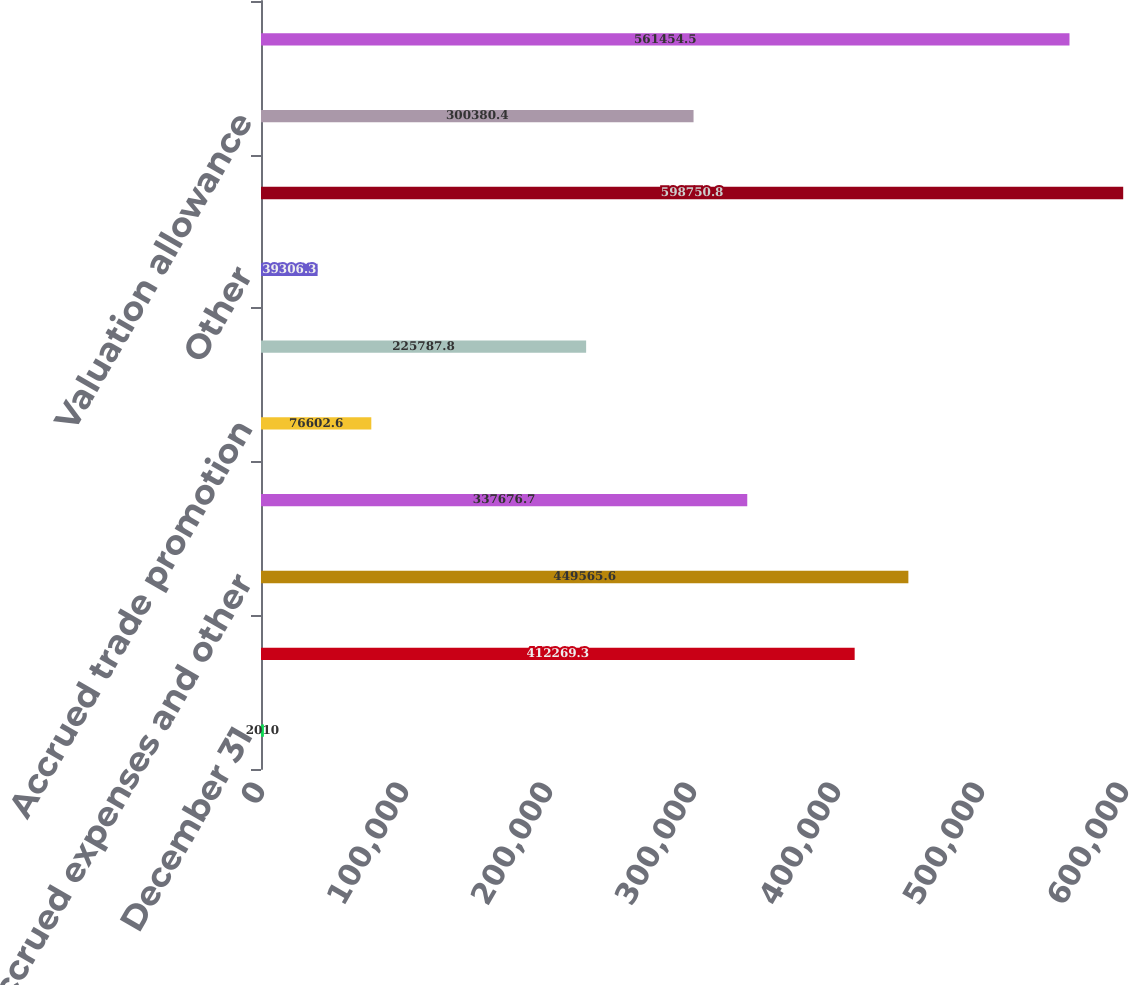<chart> <loc_0><loc_0><loc_500><loc_500><bar_chart><fcel>December 31<fcel>Post-retirement benefit<fcel>Accrued expenses and other<fcel>Stock-based compensation<fcel>Accrued trade promotion<fcel>Net operating loss<fcel>Other<fcel>Gross deferred tax assets<fcel>Valuation allowance<fcel>Total deferred tax assets<nl><fcel>2010<fcel>412269<fcel>449566<fcel>337677<fcel>76602.6<fcel>225788<fcel>39306.3<fcel>598751<fcel>300380<fcel>561454<nl></chart> 